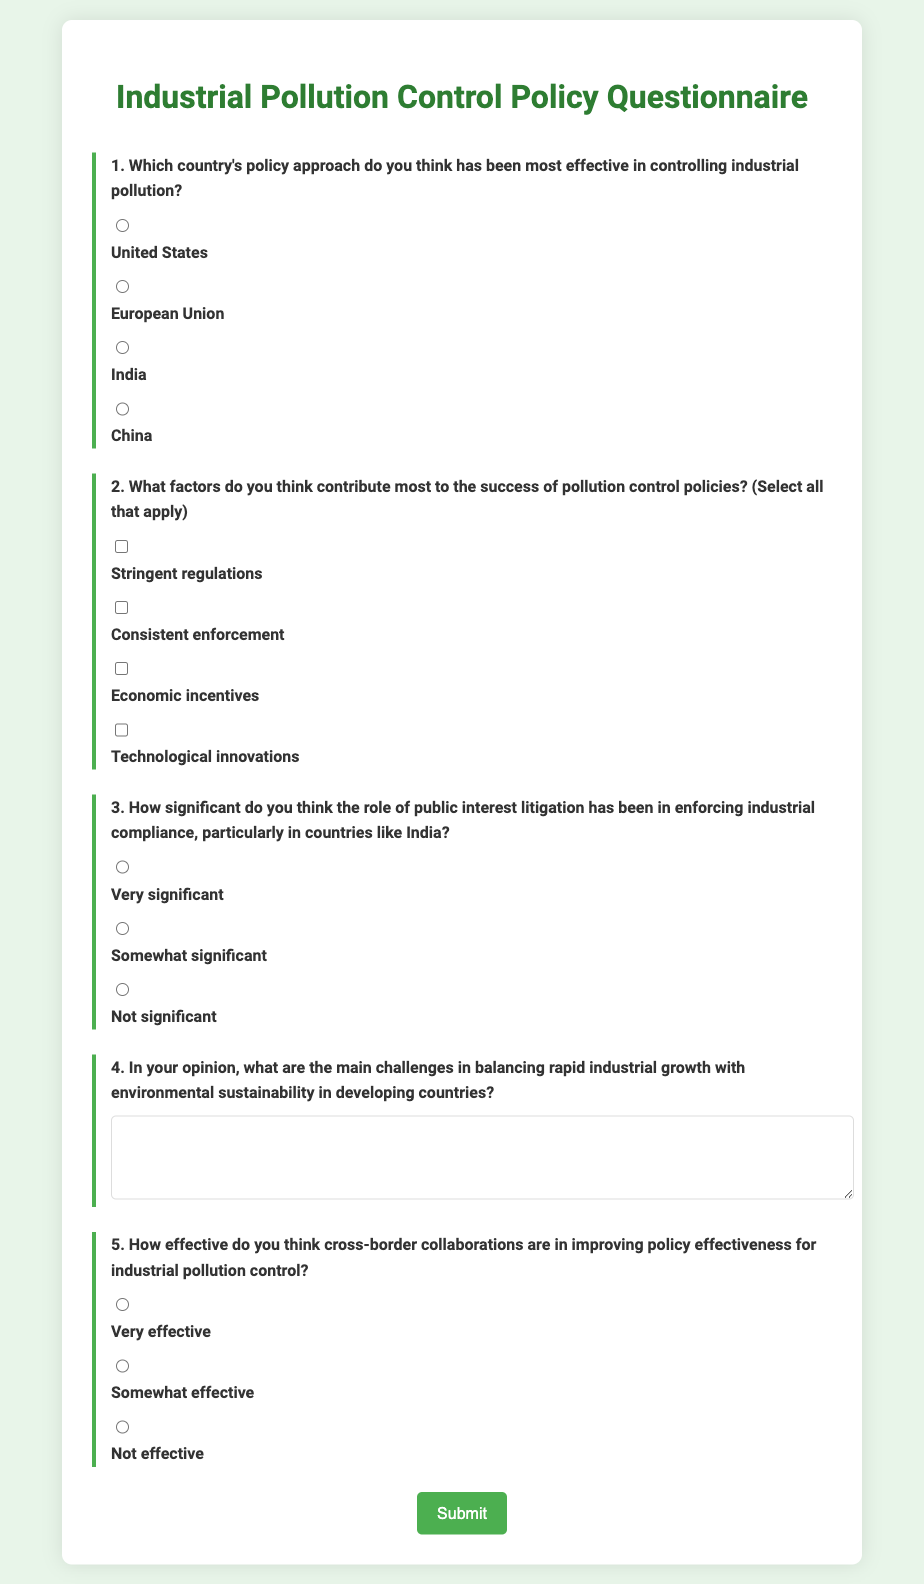What is the title of the questionnaire? The title of the questionnaire is clearly stated at the top of the document.
Answer: Industrial Pollution Control Policy Questionnaire How many countries are mentioned in the effective policy question? The question provides four options, indicating how many different countries' policies are being compared.
Answer: Four What are the four key factors that respondents can select for pollution control policy success? The document lists these as the specific response options presented in the questionnaire.
Answer: Stringent regulations, Consistent enforcement, Economic incentives, Technological innovations What is the maximum number of factors that can be selected in question two? The structure allows multiple selections in that question, indicating that respondents can choose as many as they find applicable.
Answer: All that apply What is the response format for the challenges in balancing industrial growth and environmental sustainability? The document specifies that this response should be provided in a written text area, distinct from the multiple-choice questions.
Answer: Text area How many response options are provided for the significance of public interest litigation? The document outlines a specific number of radio buttons that allow selection among different levels of significance.
Answer: Three What color is the button for submitting the questionnaire? The document describes the color of the button used for submission.
Answer: Green What is the general background color of the questionnaire? The color choice is described as part of the style section in the document.
Answer: Light green 